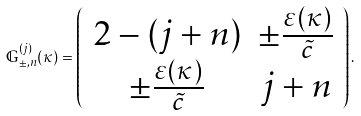Convert formula to latex. <formula><loc_0><loc_0><loc_500><loc_500>\mathbb { G } ^ { ( j ) } _ { \pm , n } ( \kappa ) = \left ( \begin{array} { c c } 2 - ( j + n ) & \pm \frac { \varepsilon ( \kappa ) } { \tilde { c } } \\ \pm \frac { \varepsilon ( \kappa ) } { \tilde { c } } & j + n \end{array} \right ) .</formula> 